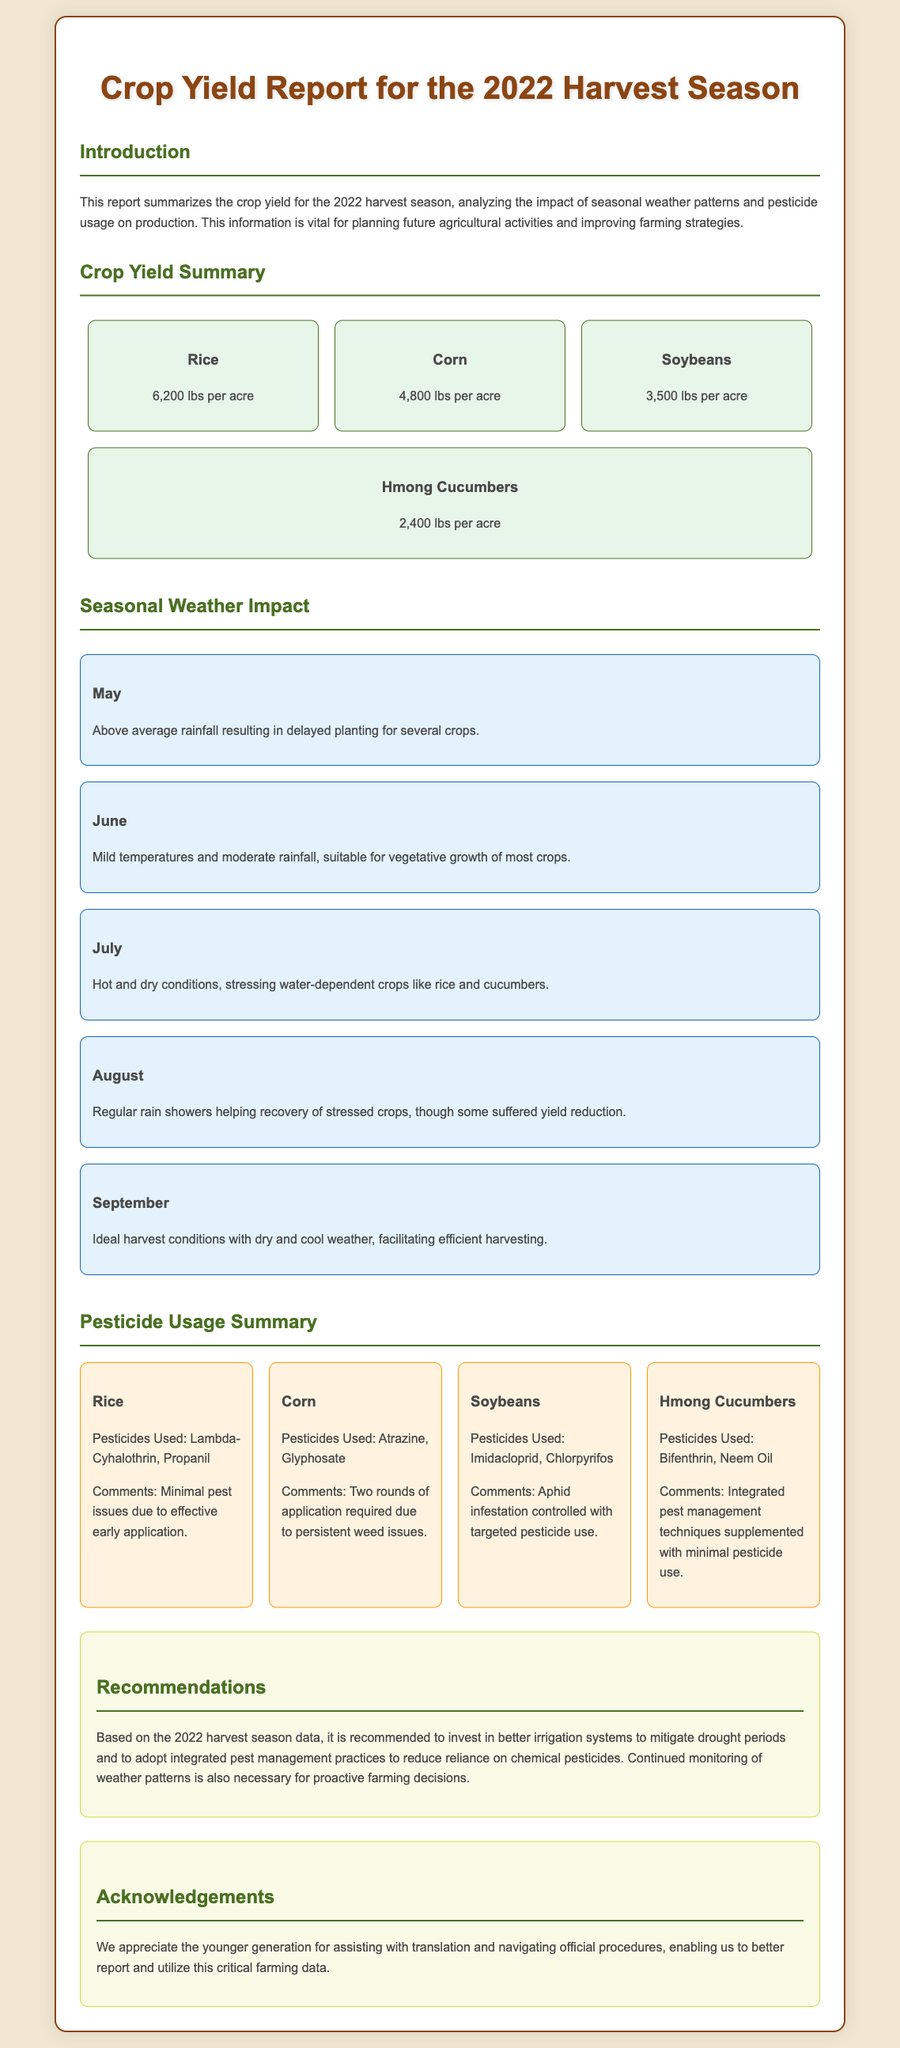What is the crop yield of rice? The crop yield of rice is noted as 6,200 lbs per acre in the document.
Answer: 6,200 lbs per acre What month had above average rainfall? The document specifies that May had above average rainfall, affecting the planting schedule.
Answer: May Which crop had a yield of 4,800 lbs per acre? The crop yield for corn is indicated as 4,800 lbs per acre in the report.
Answer: Corn What pesticides were used on soybeans? The report lists Imidacloprid and Chlorpyrifos as the pesticides used on soybeans.
Answer: Imidacloprid, Chlorpyrifos What recommendation is made regarding irrigation? The document recommends investing in better irrigation systems to help with drought periods.
Answer: Better irrigation systems Which month provided ideal harvest conditions? According to the report, September had dry and cool weather, which were ideal for harvesting.
Answer: September What was the weather condition in July? The document states that July experienced hot and dry conditions, affecting crops reliant on water.
Answer: Hot and dry What does the report say about pesticide use for Hmong Cucumbers? The report indicates that integrated pest management techniques were used with minimal pesticide application for Hmong Cucumbers.
Answer: Integrated pest management techniques What is acknowledged in the report? The document acknowledges the younger generation for their assistance with translation and navigating official procedures.
Answer: Younger generation assistance 